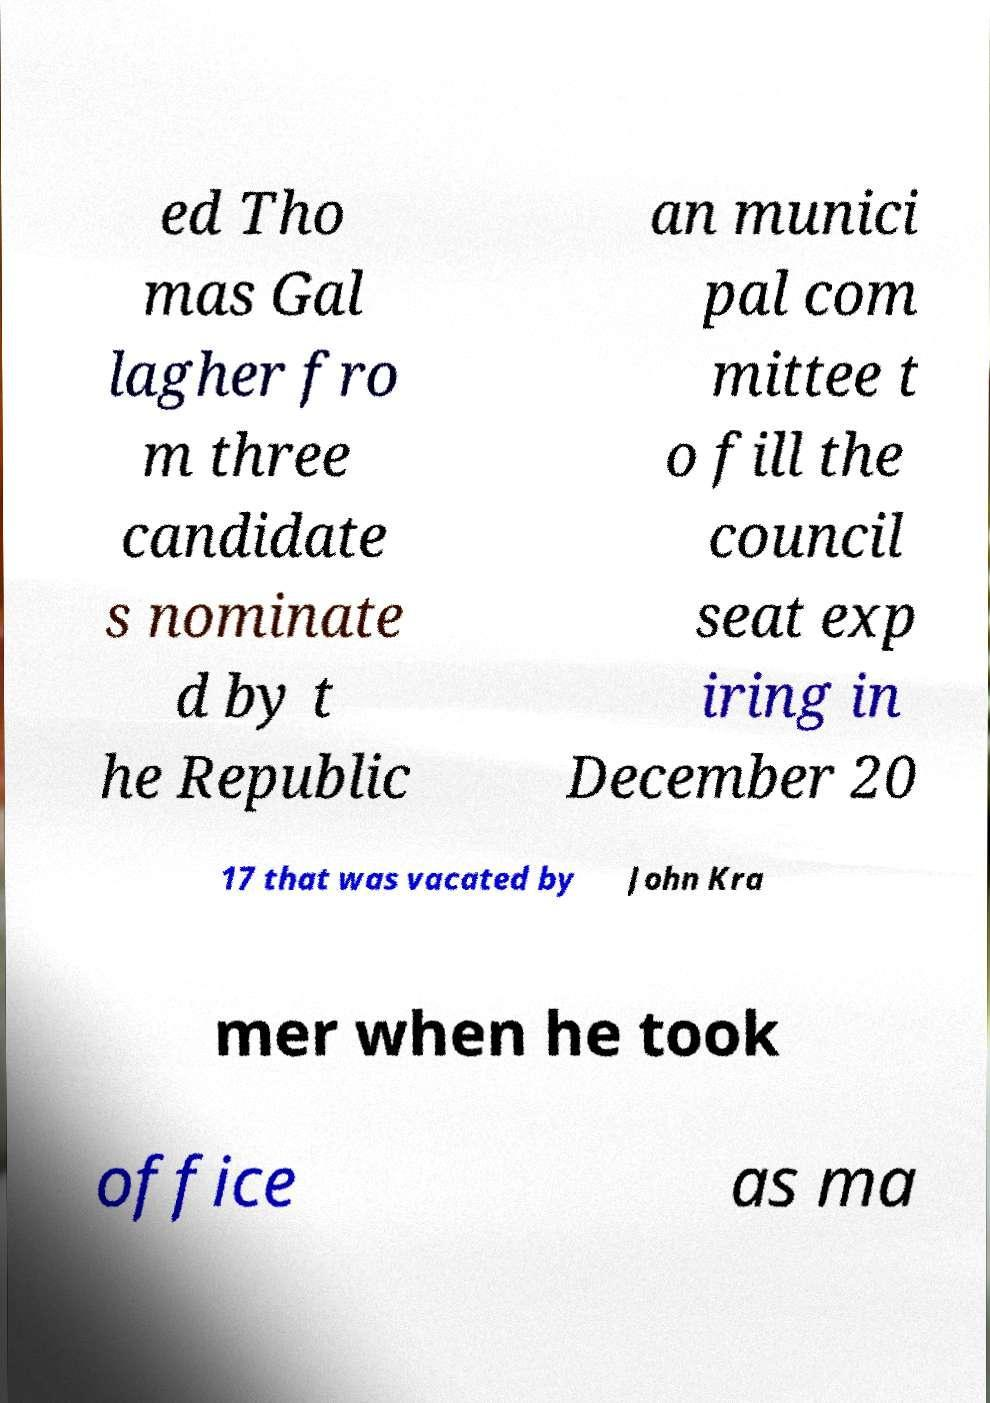What messages or text are displayed in this image? I need them in a readable, typed format. ed Tho mas Gal lagher fro m three candidate s nominate d by t he Republic an munici pal com mittee t o fill the council seat exp iring in December 20 17 that was vacated by John Kra mer when he took office as ma 